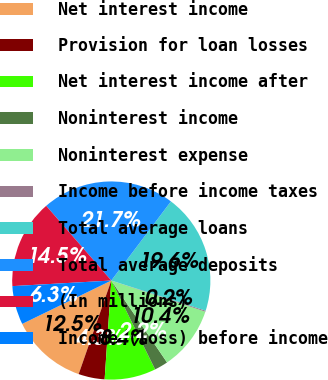<chart> <loc_0><loc_0><loc_500><loc_500><pie_chart><fcel>Net interest income<fcel>Provision for loan losses<fcel>Net interest income after<fcel>Noninterest income<fcel>Noninterest expense<fcel>Income before income taxes<fcel>Total average loans<fcel>Total average deposits<fcel>(In millions)<fcel>Income (loss) before income<nl><fcel>12.45%<fcel>4.27%<fcel>8.36%<fcel>2.22%<fcel>10.4%<fcel>0.17%<fcel>19.64%<fcel>21.69%<fcel>14.49%<fcel>6.31%<nl></chart> 